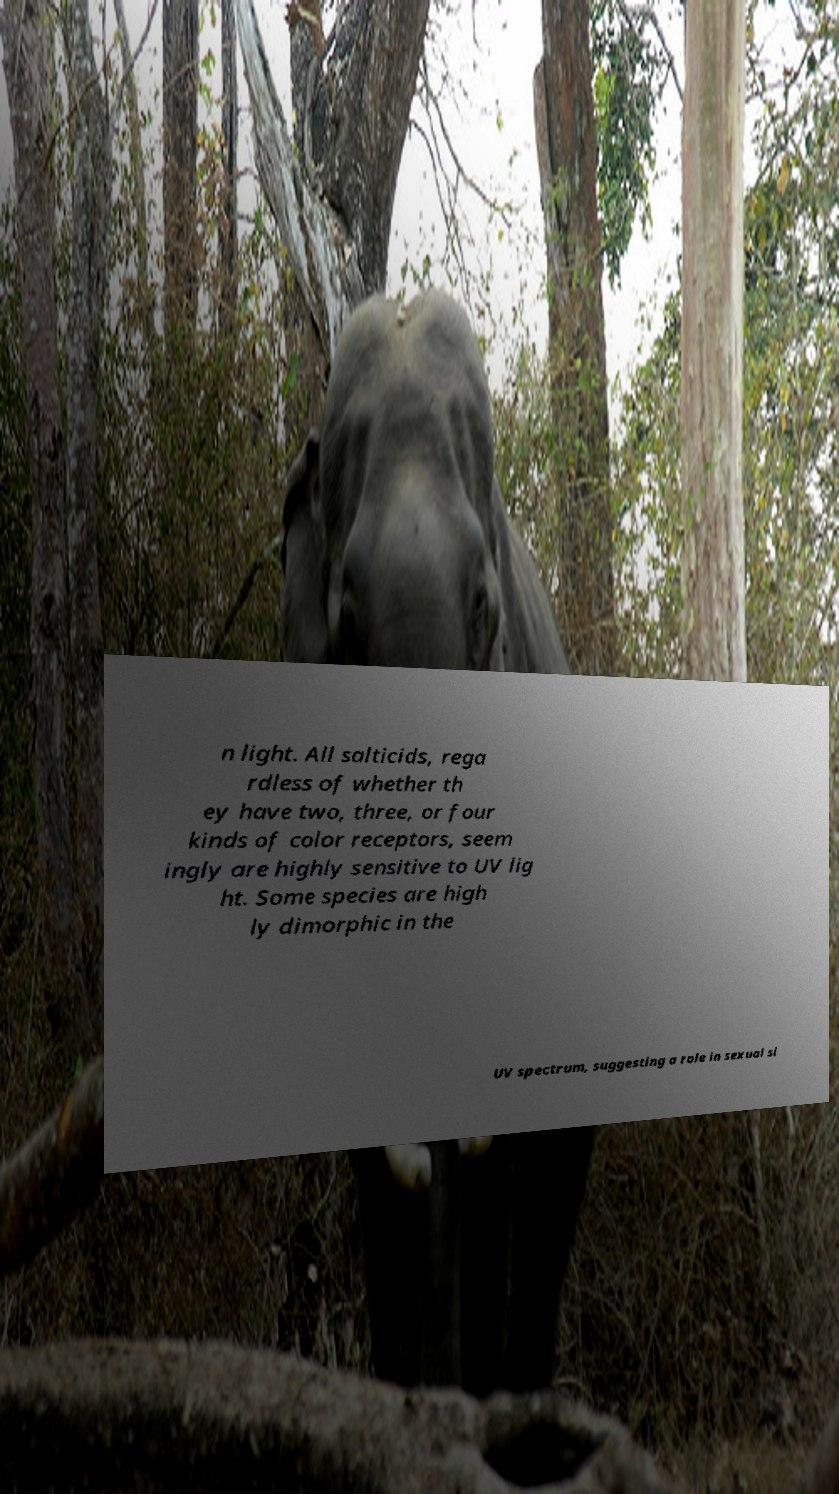There's text embedded in this image that I need extracted. Can you transcribe it verbatim? n light. All salticids, rega rdless of whether th ey have two, three, or four kinds of color receptors, seem ingly are highly sensitive to UV lig ht. Some species are high ly dimorphic in the UV spectrum, suggesting a role in sexual si 